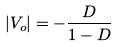<formula> <loc_0><loc_0><loc_500><loc_500>| V _ { o } | = - \frac { D } { 1 - D }</formula> 